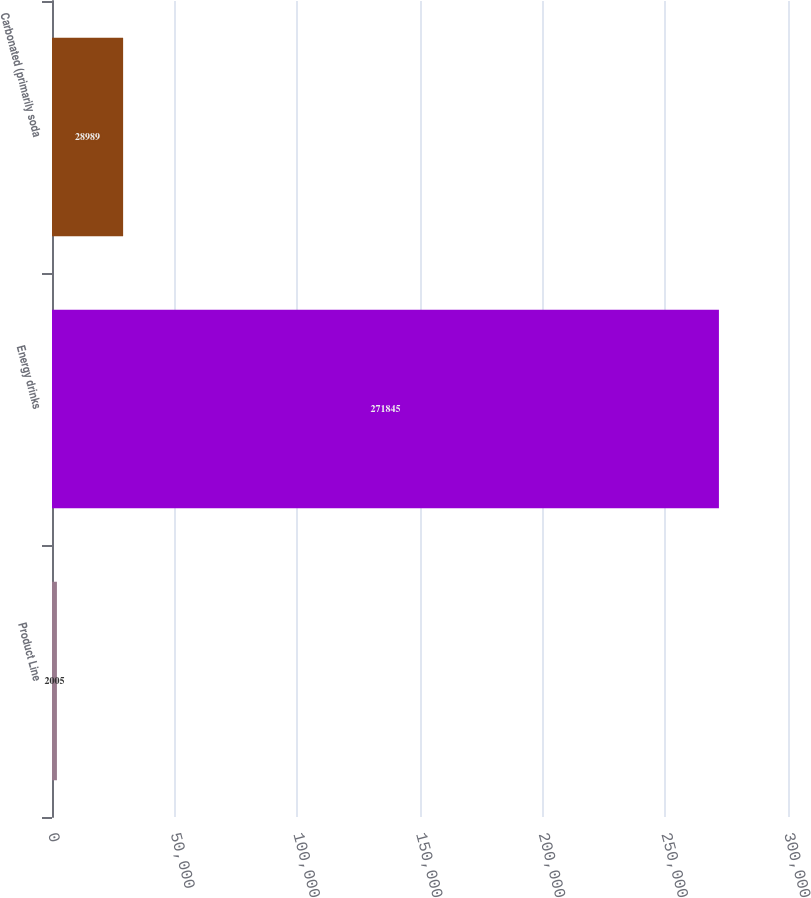Convert chart. <chart><loc_0><loc_0><loc_500><loc_500><bar_chart><fcel>Product Line<fcel>Energy drinks<fcel>Carbonated (primarily soda<nl><fcel>2005<fcel>271845<fcel>28989<nl></chart> 